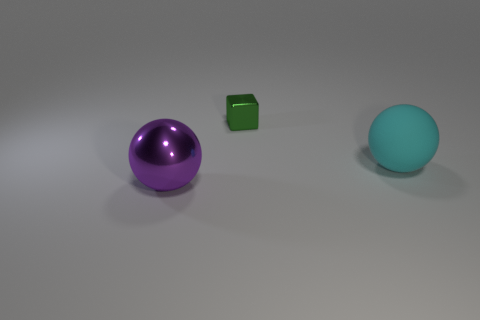Add 1 rubber balls. How many objects exist? 4 Subtract all blocks. How many objects are left? 2 Add 1 green objects. How many green objects are left? 2 Add 1 metallic balls. How many metallic balls exist? 2 Subtract 0 cyan cubes. How many objects are left? 3 Subtract all cyan rubber balls. Subtract all small red balls. How many objects are left? 2 